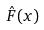<formula> <loc_0><loc_0><loc_500><loc_500>\hat { F } ( x )</formula> 